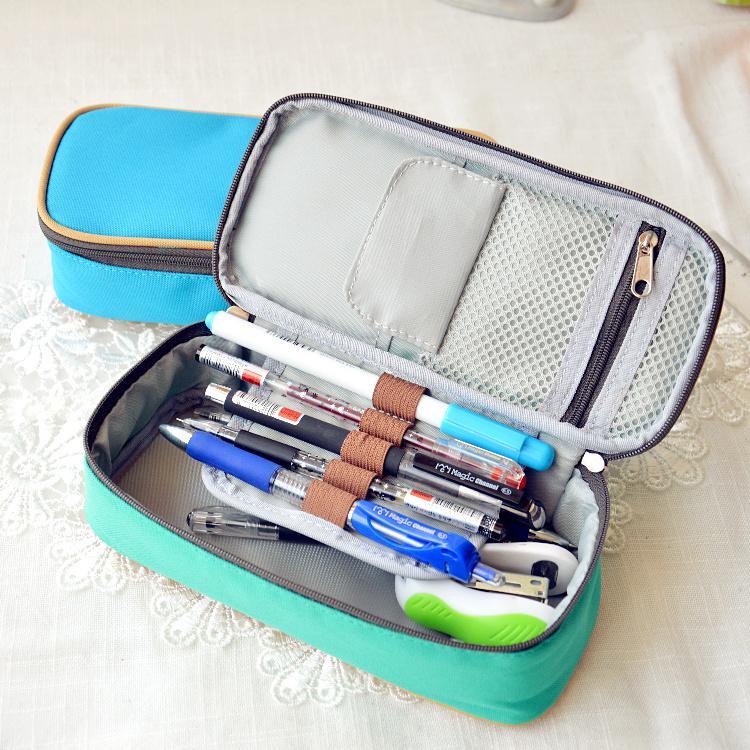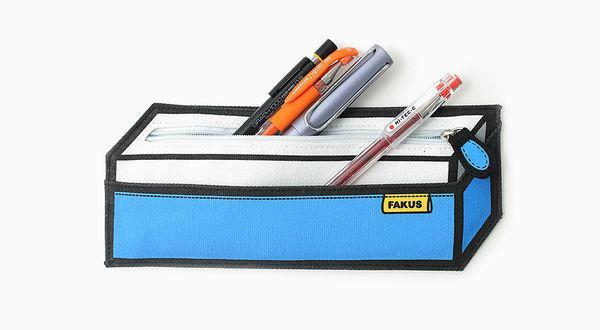The first image is the image on the left, the second image is the image on the right. Assess this claim about the two images: "There is one pink case in the image on the left.". Correct or not? Answer yes or no. No. 